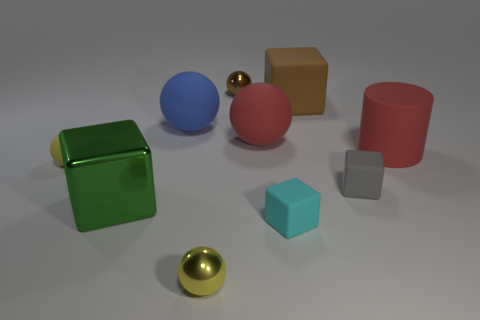Subtract all cyan matte blocks. How many blocks are left? 3 Subtract all blue cubes. How many yellow balls are left? 2 Subtract 3 spheres. How many spheres are left? 2 Subtract all cylinders. How many objects are left? 9 Subtract all cyan blocks. How many blocks are left? 3 Add 2 big metal things. How many big metal things exist? 3 Subtract 0 yellow cubes. How many objects are left? 10 Subtract all purple cylinders. Subtract all yellow spheres. How many cylinders are left? 1 Subtract all small yellow metal objects. Subtract all small brown cubes. How many objects are left? 9 Add 2 tiny yellow rubber objects. How many tiny yellow rubber objects are left? 3 